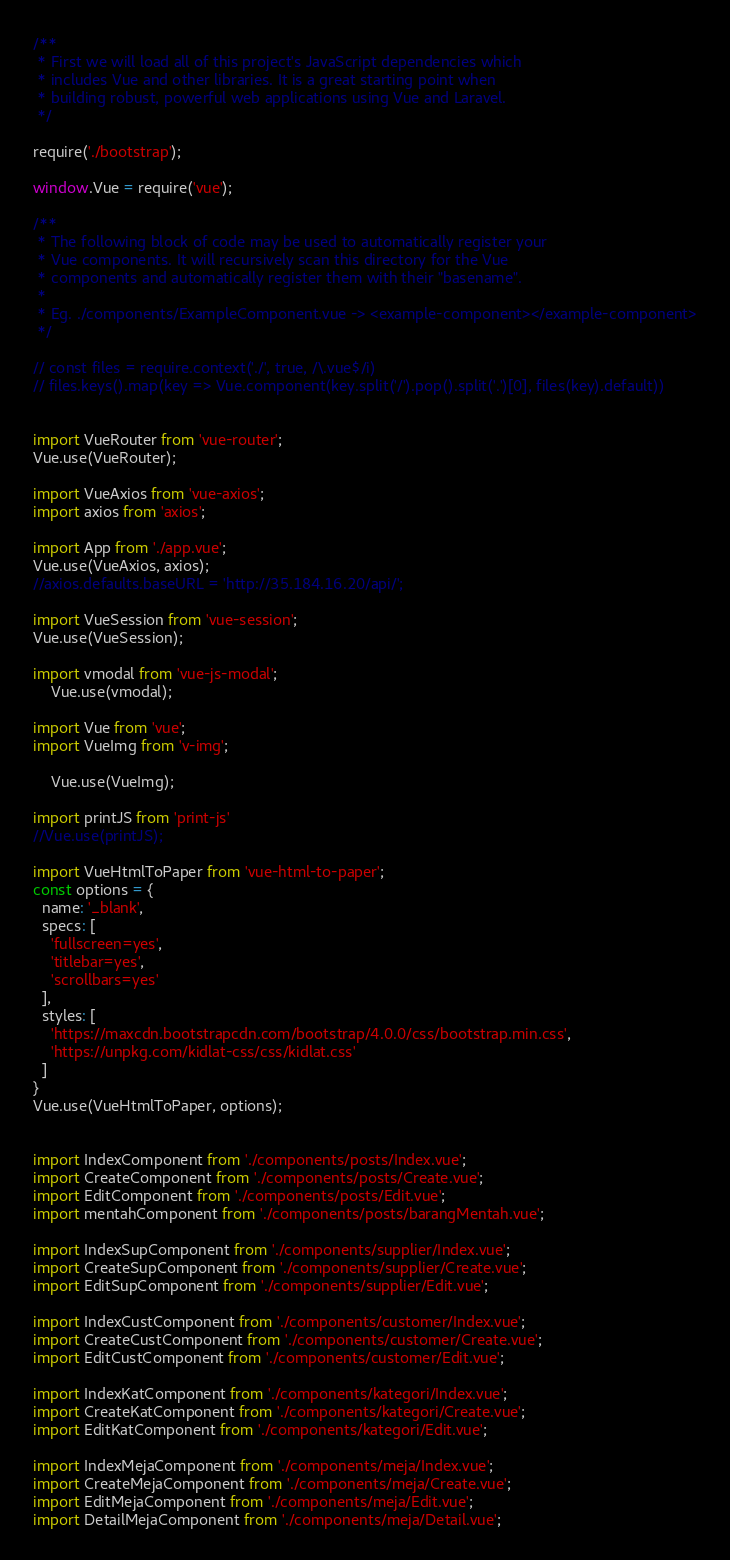Convert code to text. <code><loc_0><loc_0><loc_500><loc_500><_JavaScript_>/**
 * First we will load all of this project's JavaScript dependencies which
 * includes Vue and other libraries. It is a great starting point when
 * building robust, powerful web applications using Vue and Laravel.
 */

require('./bootstrap');

window.Vue = require('vue');

/**
 * The following block of code may be used to automatically register your
 * Vue components. It will recursively scan this directory for the Vue
 * components and automatically register them with their "basename".
 *
 * Eg. ./components/ExampleComponent.vue -> <example-component></example-component>
 */

// const files = require.context('./', true, /\.vue$/i)
// files.keys().map(key => Vue.component(key.split('/').pop().split('.')[0], files(key).default))


import VueRouter from 'vue-router';
Vue.use(VueRouter);

import VueAxios from 'vue-axios';
import axios from 'axios';

import App from './app.vue';
Vue.use(VueAxios, axios);
//axios.defaults.baseURL = 'http://35.184.16.20/api/';

import VueSession from 'vue-session';
Vue.use(VueSession);

import vmodal from 'vue-js-modal';
    Vue.use(vmodal);

import Vue from 'vue';
import VueImg from 'v-img';
    
    Vue.use(VueImg);

import printJS from 'print-js'
//Vue.use(printJS);

import VueHtmlToPaper from 'vue-html-to-paper';
const options = {
  name: '_blank',
  specs: [
    'fullscreen=yes',
    'titlebar=yes',
    'scrollbars=yes'
  ],
  styles: [
    'https://maxcdn.bootstrapcdn.com/bootstrap/4.0.0/css/bootstrap.min.css',
    'https://unpkg.com/kidlat-css/css/kidlat.css'
  ]
}
Vue.use(VueHtmlToPaper, options);


import IndexComponent from './components/posts/Index.vue';
import CreateComponent from './components/posts/Create.vue';
import EditComponent from './components/posts/Edit.vue';
import mentahComponent from './components/posts/barangMentah.vue';

import IndexSupComponent from './components/supplier/Index.vue';
import CreateSupComponent from './components/supplier/Create.vue';
import EditSupComponent from './components/supplier/Edit.vue';

import IndexCustComponent from './components/customer/Index.vue';
import CreateCustComponent from './components/customer/Create.vue';
import EditCustComponent from './components/customer/Edit.vue';

import IndexKatComponent from './components/kategori/Index.vue';
import CreateKatComponent from './components/kategori/Create.vue';
import EditKatComponent from './components/kategori/Edit.vue';

import IndexMejaComponent from './components/meja/Index.vue';
import CreateMejaComponent from './components/meja/Create.vue';
import EditMejaComponent from './components/meja/Edit.vue';
import DetailMejaComponent from './components/meja/Detail.vue';
</code> 